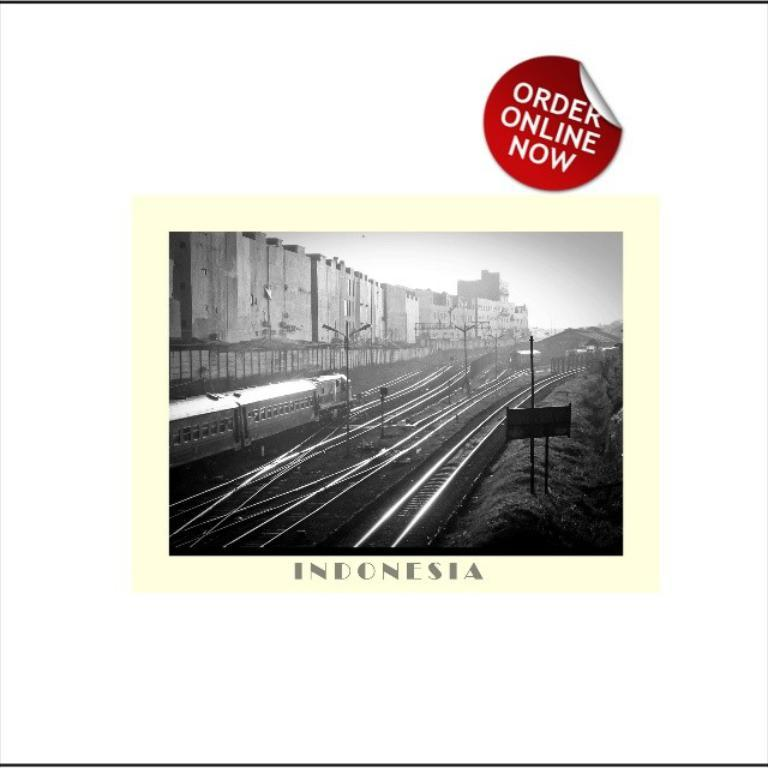Provide a one-sentence caption for the provided image. A train near several rail track crossings in Indonesia that can be Ordered Online. 